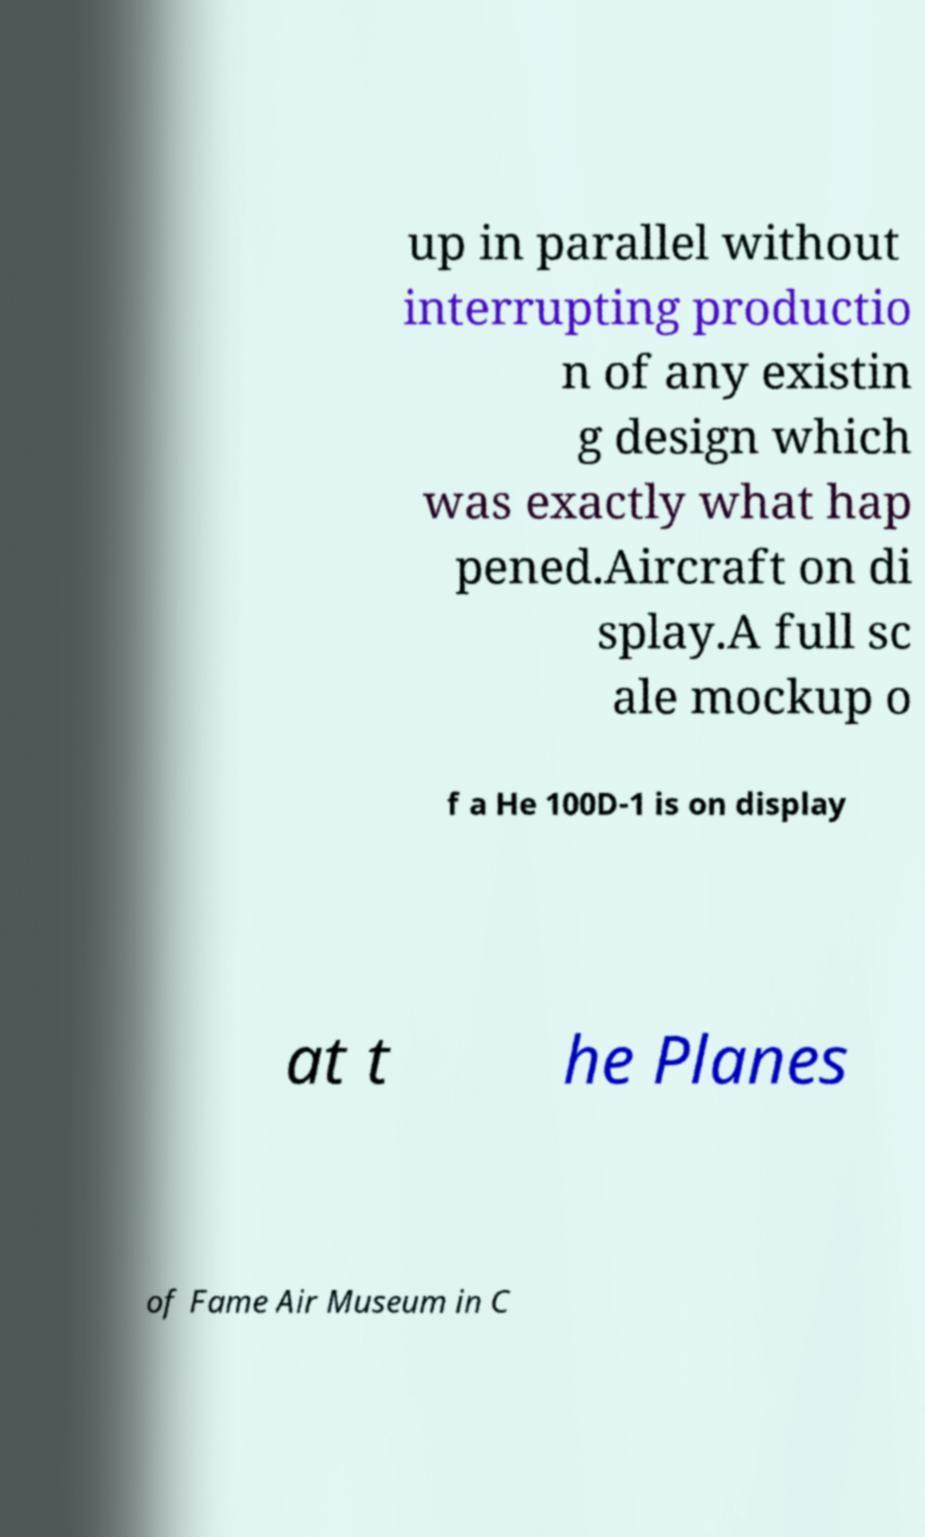What messages or text are displayed in this image? I need them in a readable, typed format. up in parallel without interrupting productio n of any existin g design which was exactly what hap pened.Aircraft on di splay.A full sc ale mockup o f a He 100D-1 is on display at t he Planes of Fame Air Museum in C 